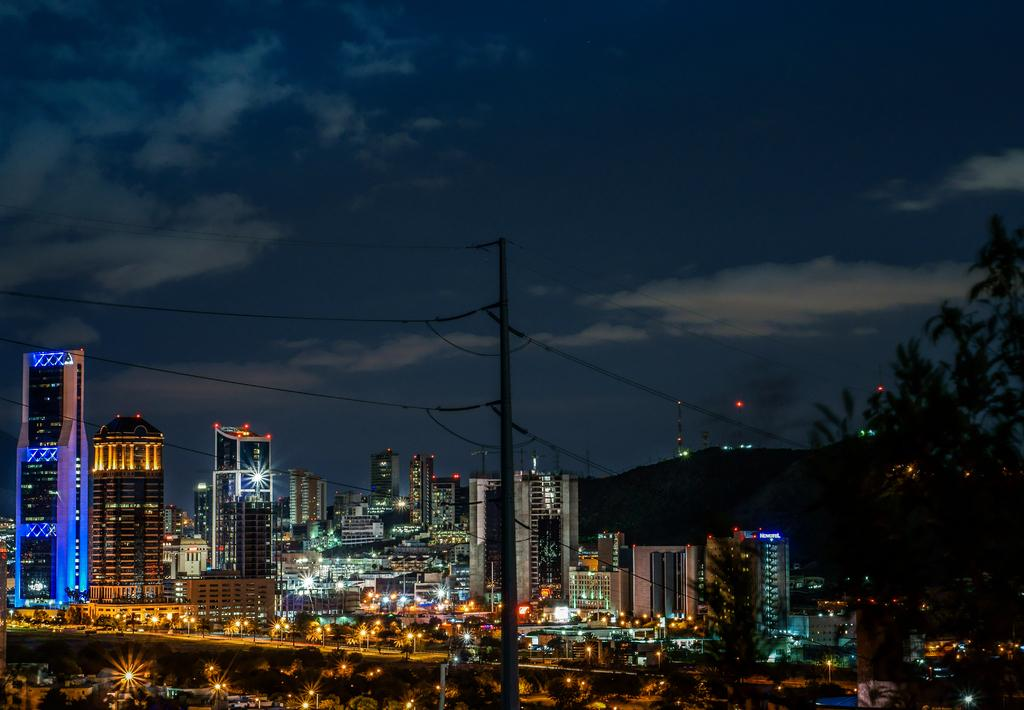What can be found at the bottom of the image? There are poles, trees, and buildings at the bottom of the image. What is visible in the sky at the top of the image? There are clouds and the sky visible at the top of the image. Can you hear the animals whistling at the zoo in the image? There is no zoo or animals present in the image, so it is not possible to hear any whistling. 